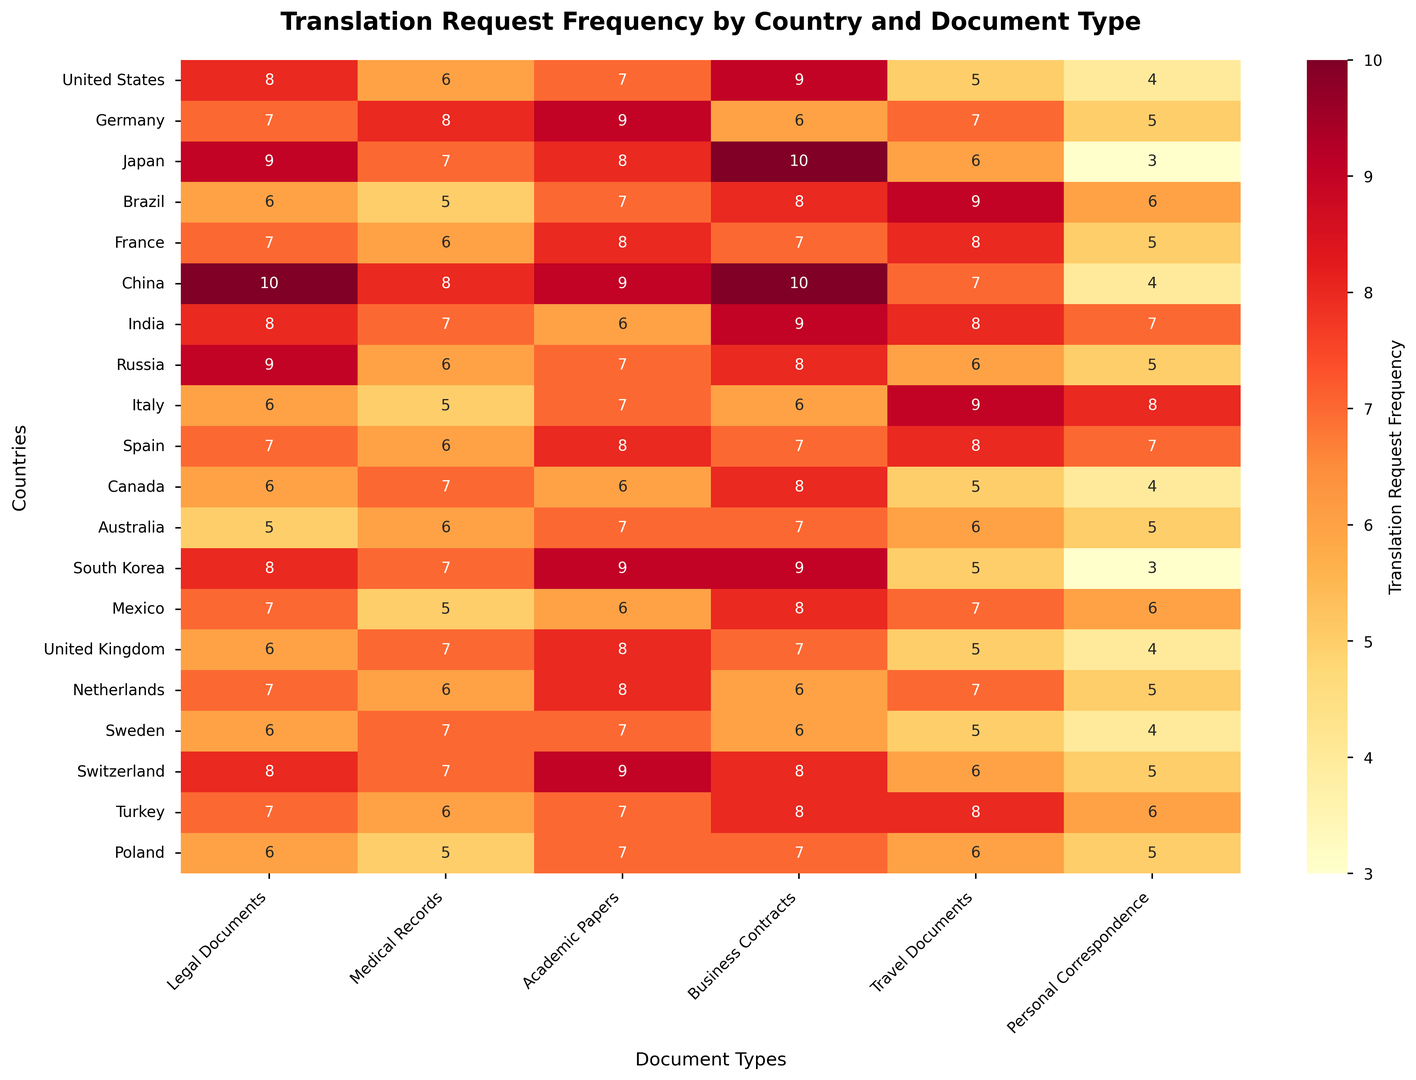Which country has the highest frequency of translation requests for legal documents? Look at the "Legal Documents" column and identify the country with the highest number, which is 10 in China.
Answer: China Which document type has the lowest translation request frequency in Brazil? Look at the row for Brazil and find the lowest number, which is 5 for "Medical Records".
Answer: Medical Records What is the average translation request frequency for academic papers in all countries? Sum the translation request frequencies for "Academic Papers" across all countries (7 + 9 + 8 + 7 + 8 + 9 + 6 + 7 + 7 + 8 + 6 + 7 + 9 + 6 + 8 + 8 + 7 + 9 + 7 + 7) = 139. Divide by the number of countries (20). So, 139/20 = 6.95.
Answer: 6.95 Between the United States and Japan, which country has a higher frequency of translation requests for business contracts? Compare the numbers for "Business Contracts" in the United States (9) and Japan (10). Japan has a higher frequency.
Answer: Japan What is the total translation request frequency for all document types in Sweden? Add the frequencies for all document types in Sweden: 6 (Legal Documents) + 7 (Medical Records) + 7 (Academic Papers) + 6 (Business Contracts) + 5 (Travel Documents) + 4 (Personal Correspondence) = 35.
Answer: 35 Compare the translation request frequency for travel documents and personal correspondence across China. Which one is higher? Look at the values in the China row for "Travel Documents" (7) and "Personal Correspondence" (4). "Travel Documents" has a higher frequency.
Answer: Travel Documents Which document type has similar translation request frequencies (within a margin of 1) in both Mexico and Turkey? Compare each document type's frequencies in Mexico and Turkey: "Legal Documents" (7, 7), "Medical Records" (5, 6), "Academic Papers" (6, 7), "Business Contracts" (8, 8), "Travel Documents" (7, 8), "Personal Correspondence" (6, 6). All have frequencies within a margin of 1, except "Legal Documents".
Answer: Business Contracts, Personal Correspondence What is the median translation request frequency for personal correspondence across all countries? Arrange the data for "Personal Correspondence" in order: 3, 3, 4, 4, 4, 4, 5, 5, 5, 5, 5, 6, 6, 6, 7, 7, 7, 7, 8, 8. The median is the average of the 10th and 11th terms (5, 5), which is 5.
Answer: 5 